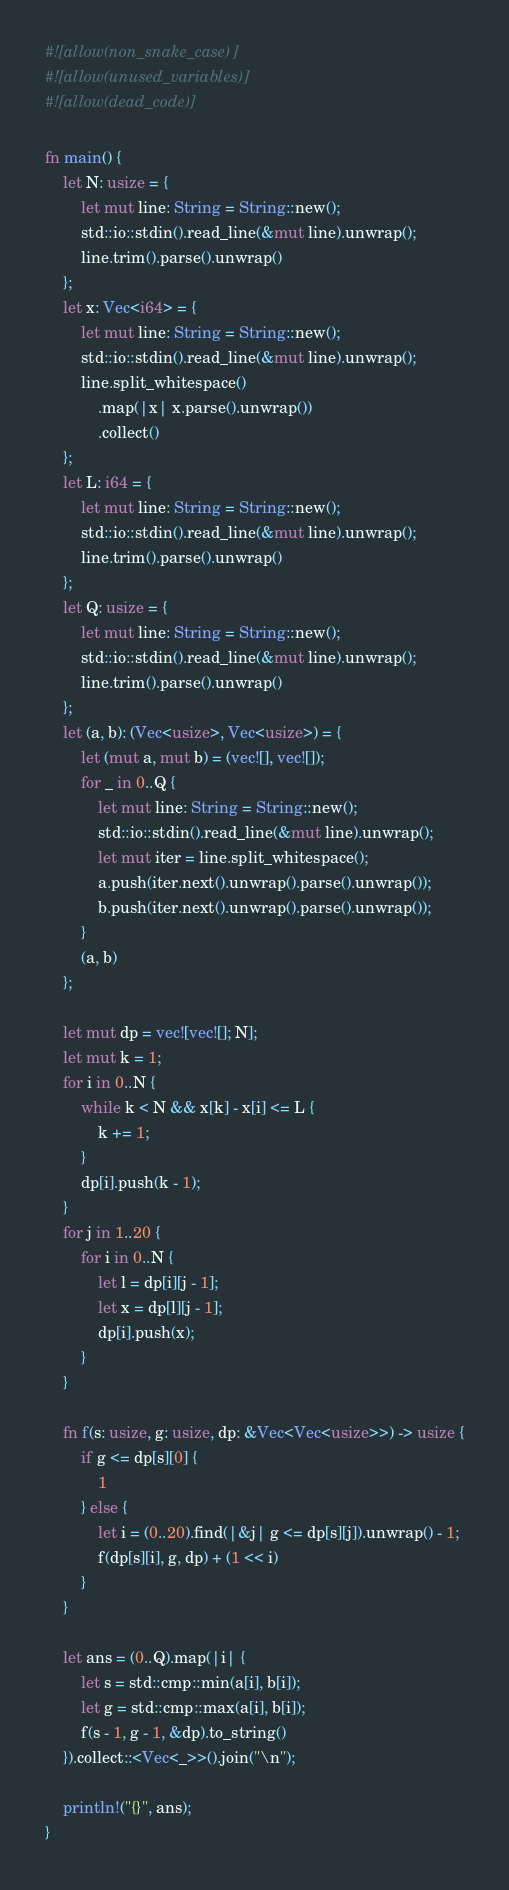Convert code to text. <code><loc_0><loc_0><loc_500><loc_500><_Rust_>#![allow(non_snake_case)]
#![allow(unused_variables)]
#![allow(dead_code)]

fn main() {
    let N: usize = {
        let mut line: String = String::new();
        std::io::stdin().read_line(&mut line).unwrap();
        line.trim().parse().unwrap()
    };
    let x: Vec<i64> = {
        let mut line: String = String::new();
        std::io::stdin().read_line(&mut line).unwrap();
        line.split_whitespace()
            .map(|x| x.parse().unwrap())
            .collect()
    };
    let L: i64 = {
        let mut line: String = String::new();
        std::io::stdin().read_line(&mut line).unwrap();
        line.trim().parse().unwrap()
    };
    let Q: usize = {
        let mut line: String = String::new();
        std::io::stdin().read_line(&mut line).unwrap();
        line.trim().parse().unwrap()
    };
    let (a, b): (Vec<usize>, Vec<usize>) = {
        let (mut a, mut b) = (vec![], vec![]);
        for _ in 0..Q {
            let mut line: String = String::new();
            std::io::stdin().read_line(&mut line).unwrap();
            let mut iter = line.split_whitespace();
            a.push(iter.next().unwrap().parse().unwrap());
            b.push(iter.next().unwrap().parse().unwrap());
        }
        (a, b)
    };

    let mut dp = vec![vec![]; N];
    let mut k = 1;
    for i in 0..N {
        while k < N && x[k] - x[i] <= L {
            k += 1;
        }
        dp[i].push(k - 1);
    }
    for j in 1..20 {
        for i in 0..N {
            let l = dp[i][j - 1];
            let x = dp[l][j - 1];
            dp[i].push(x);
        }
    }

    fn f(s: usize, g: usize, dp: &Vec<Vec<usize>>) -> usize {
        if g <= dp[s][0] {
            1
        } else {
            let i = (0..20).find(|&j| g <= dp[s][j]).unwrap() - 1;
            f(dp[s][i], g, dp) + (1 << i)
        }
    }

    let ans = (0..Q).map(|i| {
        let s = std::cmp::min(a[i], b[i]);
        let g = std::cmp::max(a[i], b[i]);
        f(s - 1, g - 1, &dp).to_string()
    }).collect::<Vec<_>>().join("\n");

    println!("{}", ans);
}</code> 